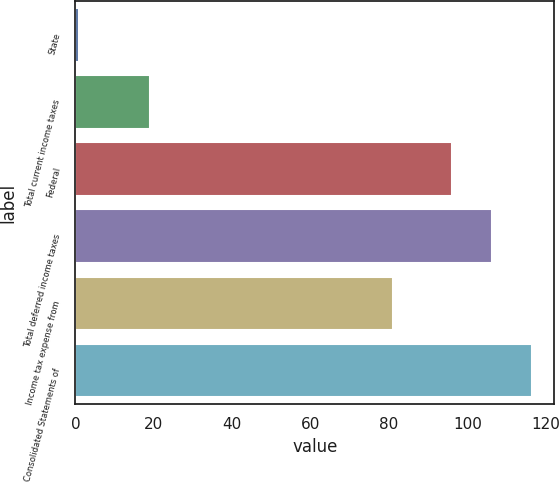<chart> <loc_0><loc_0><loc_500><loc_500><bar_chart><fcel>State<fcel>Total current income taxes<fcel>Federal<fcel>Total deferred income taxes<fcel>Income tax expense from<fcel>Consolidated Statements of<nl><fcel>1<fcel>19<fcel>96<fcel>106.2<fcel>81<fcel>116.4<nl></chart> 